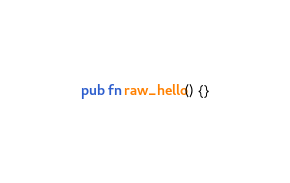Convert code to text. <code><loc_0><loc_0><loc_500><loc_500><_Rust_>pub fn raw_hello() {}
</code> 